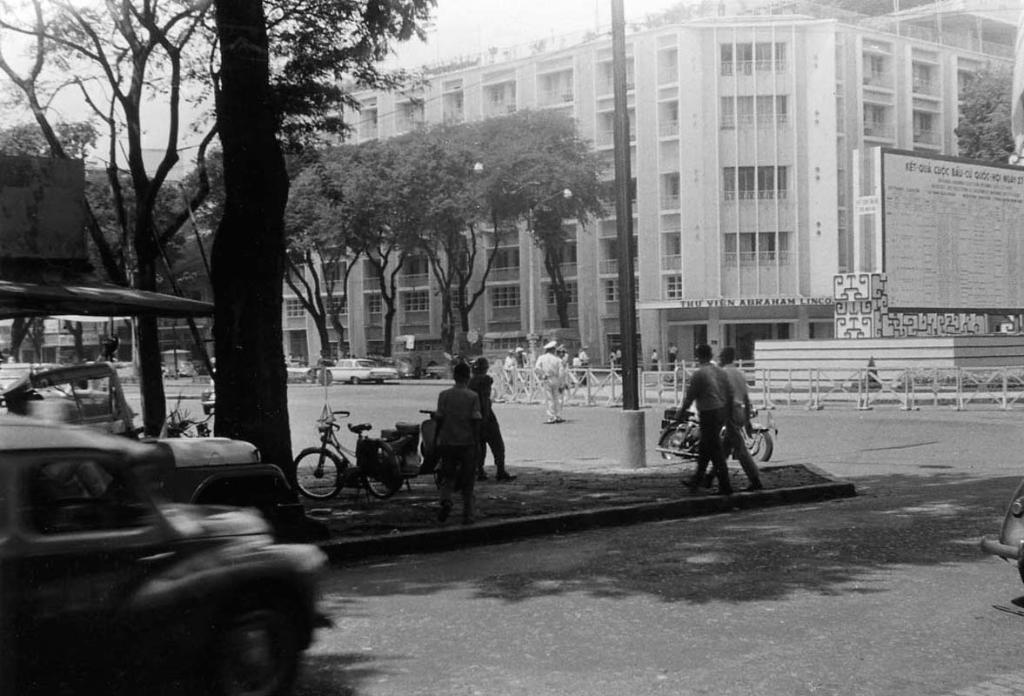Can you describe this image briefly? On the left side, there are vehicles on the road, near a divider, on which, there is a pole, persons walking and there are vehicles parking. In the background, there are persons and vehicles on the road, there are trees, buildings and there is a sky. 